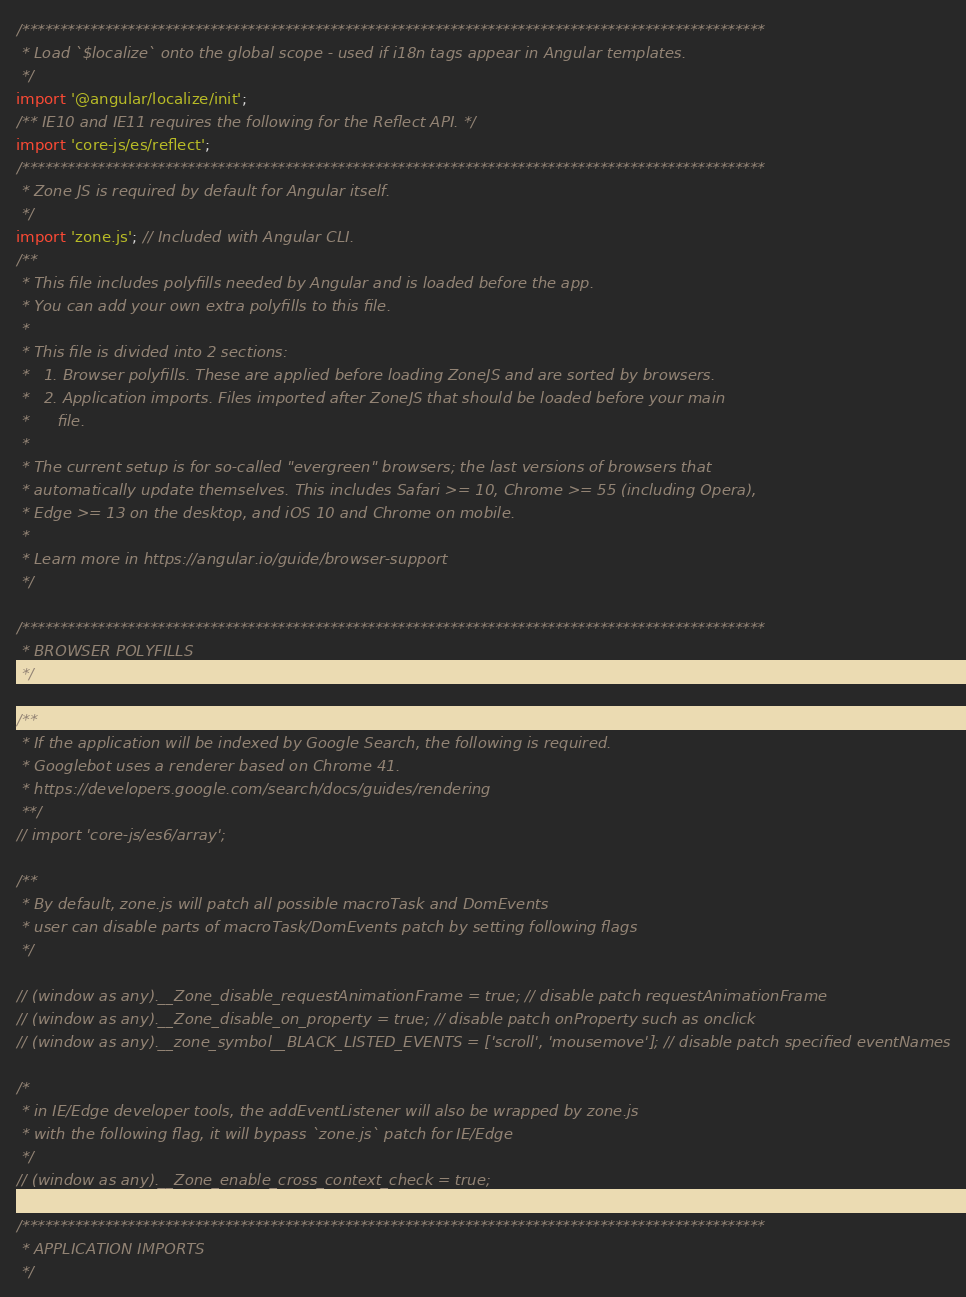<code> <loc_0><loc_0><loc_500><loc_500><_TypeScript_>/***************************************************************************************************
 * Load `$localize` onto the global scope - used if i18n tags appear in Angular templates.
 */
import '@angular/localize/init';
/** IE10 and IE11 requires the following for the Reflect API. */
import 'core-js/es/reflect';
/***************************************************************************************************
 * Zone JS is required by default for Angular itself.
 */
import 'zone.js'; // Included with Angular CLI.
/**
 * This file includes polyfills needed by Angular and is loaded before the app.
 * You can add your own extra polyfills to this file.
 *
 * This file is divided into 2 sections:
 *   1. Browser polyfills. These are applied before loading ZoneJS and are sorted by browsers.
 *   2. Application imports. Files imported after ZoneJS that should be loaded before your main
 *      file.
 *
 * The current setup is for so-called "evergreen" browsers; the last versions of browsers that
 * automatically update themselves. This includes Safari >= 10, Chrome >= 55 (including Opera),
 * Edge >= 13 on the desktop, and iOS 10 and Chrome on mobile.
 *
 * Learn more in https://angular.io/guide/browser-support
 */

/***************************************************************************************************
 * BROWSER POLYFILLS
 */

/**
 * If the application will be indexed by Google Search, the following is required.
 * Googlebot uses a renderer based on Chrome 41.
 * https://developers.google.com/search/docs/guides/rendering
 **/
// import 'core-js/es6/array';

/**
 * By default, zone.js will patch all possible macroTask and DomEvents
 * user can disable parts of macroTask/DomEvents patch by setting following flags
 */

// (window as any).__Zone_disable_requestAnimationFrame = true; // disable patch requestAnimationFrame
// (window as any).__Zone_disable_on_property = true; // disable patch onProperty such as onclick
// (window as any).__zone_symbol__BLACK_LISTED_EVENTS = ['scroll', 'mousemove']; // disable patch specified eventNames

/*
 * in IE/Edge developer tools, the addEventListener will also be wrapped by zone.js
 * with the following flag, it will bypass `zone.js` patch for IE/Edge
 */
// (window as any).__Zone_enable_cross_context_check = true;

/***************************************************************************************************
 * APPLICATION IMPORTS
 */
</code> 